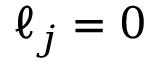<formula> <loc_0><loc_0><loc_500><loc_500>\ell _ { j } = 0</formula> 